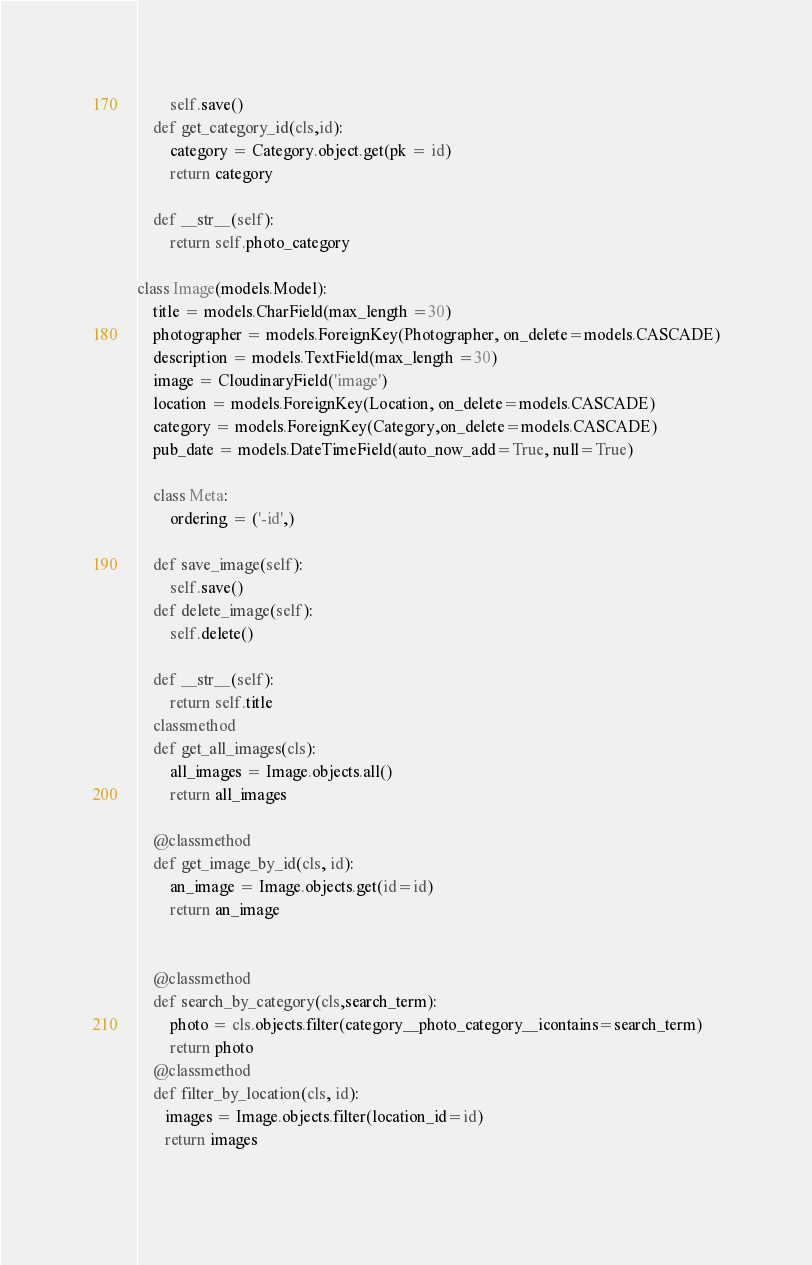Convert code to text. <code><loc_0><loc_0><loc_500><loc_500><_Python_>        self.save()
    def get_category_id(cls,id):
        category = Category.object.get(pk = id)
        return category

    def __str__(self):
        return self.photo_category 

class Image(models.Model):
    title = models.CharField(max_length =30)
    photographer = models.ForeignKey(Photographer, on_delete=models.CASCADE)
    description = models.TextField(max_length =30)
    image = CloudinaryField('image')
    location = models.ForeignKey(Location, on_delete=models.CASCADE)
    category = models.ForeignKey(Category,on_delete=models.CASCADE)
    pub_date = models.DateTimeField(auto_now_add=True, null=True) 

    class Meta:
        ordering = ('-id',)

    def save_image(self):
        self.save()
    def delete_image(self):
        self.delete()

    def __str__(self):
        return self.title    
    classmethod
    def get_all_images(cls):
        all_images = Image.objects.all()
        return all_images
    
    @classmethod
    def get_image_by_id(cls, id):
        an_image = Image.objects.get(id=id)
        return an_image    


    @classmethod
    def search_by_category(cls,search_term):
        photo = cls.objects.filter(category__photo_category__icontains=search_term)
        return photo       
    @classmethod
    def filter_by_location(cls, id):
       images = Image.objects.filter(location_id=id)
       return images
       </code> 